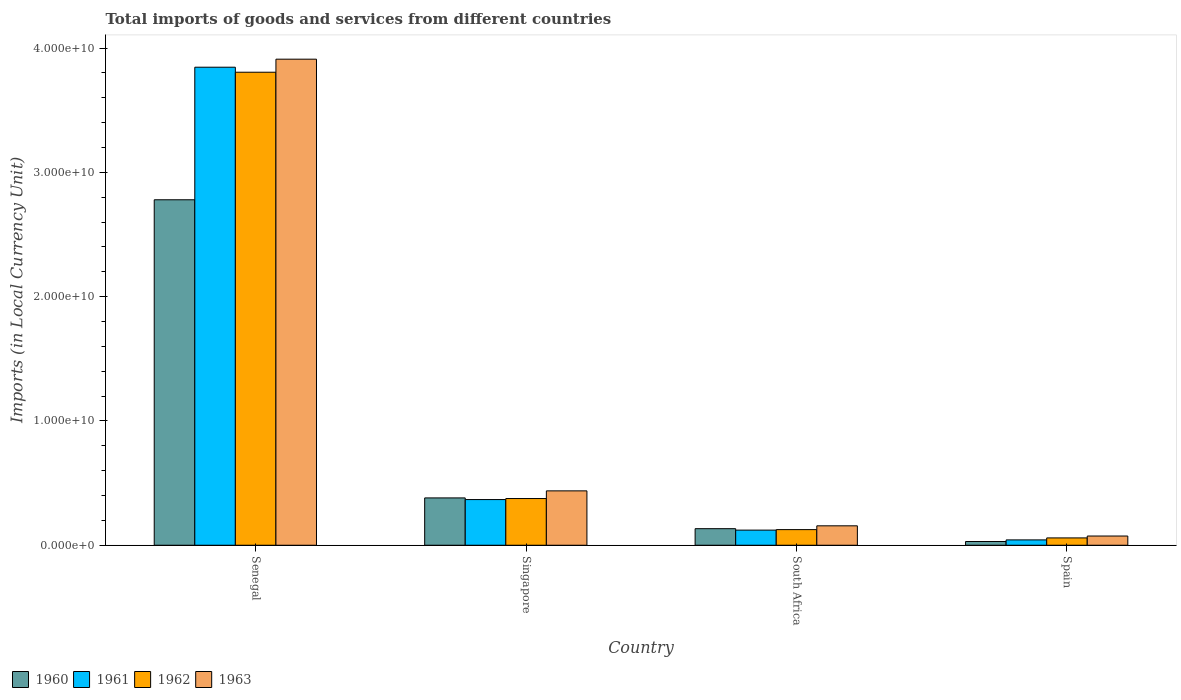Are the number of bars on each tick of the X-axis equal?
Keep it short and to the point. Yes. How many bars are there on the 3rd tick from the left?
Provide a succinct answer. 4. How many bars are there on the 1st tick from the right?
Keep it short and to the point. 4. What is the Amount of goods and services imports in 1962 in Spain?
Your response must be concise. 5.89e+08. Across all countries, what is the maximum Amount of goods and services imports in 1963?
Make the answer very short. 3.91e+1. Across all countries, what is the minimum Amount of goods and services imports in 1960?
Your response must be concise. 3.00e+08. In which country was the Amount of goods and services imports in 1963 maximum?
Provide a short and direct response. Senegal. What is the total Amount of goods and services imports in 1960 in the graph?
Provide a succinct answer. 3.32e+1. What is the difference between the Amount of goods and services imports in 1961 in Senegal and that in Singapore?
Provide a short and direct response. 3.48e+1. What is the difference between the Amount of goods and services imports in 1962 in Singapore and the Amount of goods and services imports in 1963 in Senegal?
Offer a terse response. -3.53e+1. What is the average Amount of goods and services imports in 1963 per country?
Offer a terse response. 1.14e+1. What is the difference between the Amount of goods and services imports of/in 1962 and Amount of goods and services imports of/in 1963 in South Africa?
Your answer should be compact. -3.06e+08. What is the ratio of the Amount of goods and services imports in 1962 in Singapore to that in Spain?
Offer a terse response. 6.38. What is the difference between the highest and the second highest Amount of goods and services imports in 1963?
Provide a short and direct response. -3.47e+1. What is the difference between the highest and the lowest Amount of goods and services imports in 1963?
Your response must be concise. 3.84e+1. In how many countries, is the Amount of goods and services imports in 1960 greater than the average Amount of goods and services imports in 1960 taken over all countries?
Give a very brief answer. 1. What does the 1st bar from the left in Singapore represents?
Ensure brevity in your answer.  1960. What does the 3rd bar from the right in South Africa represents?
Your answer should be very brief. 1961. How many bars are there?
Your response must be concise. 16. Are all the bars in the graph horizontal?
Make the answer very short. No. What is the difference between two consecutive major ticks on the Y-axis?
Your response must be concise. 1.00e+1. Are the values on the major ticks of Y-axis written in scientific E-notation?
Keep it short and to the point. Yes. Does the graph contain any zero values?
Your answer should be very brief. No. Where does the legend appear in the graph?
Make the answer very short. Bottom left. What is the title of the graph?
Offer a terse response. Total imports of goods and services from different countries. What is the label or title of the X-axis?
Offer a terse response. Country. What is the label or title of the Y-axis?
Your answer should be compact. Imports (in Local Currency Unit). What is the Imports (in Local Currency Unit) in 1960 in Senegal?
Provide a succinct answer. 2.78e+1. What is the Imports (in Local Currency Unit) of 1961 in Senegal?
Your answer should be compact. 3.85e+1. What is the Imports (in Local Currency Unit) in 1962 in Senegal?
Offer a very short reply. 3.81e+1. What is the Imports (in Local Currency Unit) in 1963 in Senegal?
Ensure brevity in your answer.  3.91e+1. What is the Imports (in Local Currency Unit) of 1960 in Singapore?
Your answer should be very brief. 3.81e+09. What is the Imports (in Local Currency Unit) of 1961 in Singapore?
Provide a succinct answer. 3.67e+09. What is the Imports (in Local Currency Unit) of 1962 in Singapore?
Offer a very short reply. 3.76e+09. What is the Imports (in Local Currency Unit) in 1963 in Singapore?
Provide a succinct answer. 4.37e+09. What is the Imports (in Local Currency Unit) of 1960 in South Africa?
Ensure brevity in your answer.  1.33e+09. What is the Imports (in Local Currency Unit) in 1961 in South Africa?
Offer a very short reply. 1.22e+09. What is the Imports (in Local Currency Unit) in 1962 in South Africa?
Keep it short and to the point. 1.26e+09. What is the Imports (in Local Currency Unit) in 1963 in South Africa?
Your response must be concise. 1.56e+09. What is the Imports (in Local Currency Unit) of 1960 in Spain?
Your answer should be compact. 3.00e+08. What is the Imports (in Local Currency Unit) in 1961 in Spain?
Ensure brevity in your answer.  4.29e+08. What is the Imports (in Local Currency Unit) of 1962 in Spain?
Ensure brevity in your answer.  5.89e+08. What is the Imports (in Local Currency Unit) of 1963 in Spain?
Offer a very short reply. 7.42e+08. Across all countries, what is the maximum Imports (in Local Currency Unit) of 1960?
Give a very brief answer. 2.78e+1. Across all countries, what is the maximum Imports (in Local Currency Unit) of 1961?
Give a very brief answer. 3.85e+1. Across all countries, what is the maximum Imports (in Local Currency Unit) of 1962?
Provide a short and direct response. 3.81e+1. Across all countries, what is the maximum Imports (in Local Currency Unit) in 1963?
Ensure brevity in your answer.  3.91e+1. Across all countries, what is the minimum Imports (in Local Currency Unit) of 1960?
Your answer should be compact. 3.00e+08. Across all countries, what is the minimum Imports (in Local Currency Unit) of 1961?
Keep it short and to the point. 4.29e+08. Across all countries, what is the minimum Imports (in Local Currency Unit) in 1962?
Provide a succinct answer. 5.89e+08. Across all countries, what is the minimum Imports (in Local Currency Unit) of 1963?
Your response must be concise. 7.42e+08. What is the total Imports (in Local Currency Unit) in 1960 in the graph?
Your answer should be compact. 3.32e+1. What is the total Imports (in Local Currency Unit) of 1961 in the graph?
Offer a very short reply. 4.38e+1. What is the total Imports (in Local Currency Unit) of 1962 in the graph?
Keep it short and to the point. 4.37e+1. What is the total Imports (in Local Currency Unit) of 1963 in the graph?
Your answer should be very brief. 4.58e+1. What is the difference between the Imports (in Local Currency Unit) of 1960 in Senegal and that in Singapore?
Make the answer very short. 2.40e+1. What is the difference between the Imports (in Local Currency Unit) in 1961 in Senegal and that in Singapore?
Ensure brevity in your answer.  3.48e+1. What is the difference between the Imports (in Local Currency Unit) of 1962 in Senegal and that in Singapore?
Your response must be concise. 3.43e+1. What is the difference between the Imports (in Local Currency Unit) in 1963 in Senegal and that in Singapore?
Offer a very short reply. 3.47e+1. What is the difference between the Imports (in Local Currency Unit) in 1960 in Senegal and that in South Africa?
Provide a short and direct response. 2.65e+1. What is the difference between the Imports (in Local Currency Unit) of 1961 in Senegal and that in South Africa?
Make the answer very short. 3.72e+1. What is the difference between the Imports (in Local Currency Unit) in 1962 in Senegal and that in South Africa?
Offer a terse response. 3.68e+1. What is the difference between the Imports (in Local Currency Unit) of 1963 in Senegal and that in South Africa?
Your response must be concise. 3.75e+1. What is the difference between the Imports (in Local Currency Unit) of 1960 in Senegal and that in Spain?
Offer a terse response. 2.75e+1. What is the difference between the Imports (in Local Currency Unit) in 1961 in Senegal and that in Spain?
Your answer should be very brief. 3.80e+1. What is the difference between the Imports (in Local Currency Unit) of 1962 in Senegal and that in Spain?
Keep it short and to the point. 3.75e+1. What is the difference between the Imports (in Local Currency Unit) in 1963 in Senegal and that in Spain?
Your answer should be compact. 3.84e+1. What is the difference between the Imports (in Local Currency Unit) in 1960 in Singapore and that in South Africa?
Provide a succinct answer. 2.48e+09. What is the difference between the Imports (in Local Currency Unit) in 1961 in Singapore and that in South Africa?
Your answer should be very brief. 2.46e+09. What is the difference between the Imports (in Local Currency Unit) of 1962 in Singapore and that in South Africa?
Ensure brevity in your answer.  2.50e+09. What is the difference between the Imports (in Local Currency Unit) of 1963 in Singapore and that in South Africa?
Keep it short and to the point. 2.81e+09. What is the difference between the Imports (in Local Currency Unit) in 1960 in Singapore and that in Spain?
Provide a short and direct response. 3.51e+09. What is the difference between the Imports (in Local Currency Unit) of 1961 in Singapore and that in Spain?
Make the answer very short. 3.25e+09. What is the difference between the Imports (in Local Currency Unit) in 1962 in Singapore and that in Spain?
Your response must be concise. 3.17e+09. What is the difference between the Imports (in Local Currency Unit) in 1963 in Singapore and that in Spain?
Keep it short and to the point. 3.63e+09. What is the difference between the Imports (in Local Currency Unit) in 1960 in South Africa and that in Spain?
Your answer should be very brief. 1.03e+09. What is the difference between the Imports (in Local Currency Unit) of 1961 in South Africa and that in Spain?
Make the answer very short. 7.87e+08. What is the difference between the Imports (in Local Currency Unit) of 1962 in South Africa and that in Spain?
Offer a very short reply. 6.68e+08. What is the difference between the Imports (in Local Currency Unit) in 1963 in South Africa and that in Spain?
Your answer should be compact. 8.21e+08. What is the difference between the Imports (in Local Currency Unit) of 1960 in Senegal and the Imports (in Local Currency Unit) of 1961 in Singapore?
Your answer should be very brief. 2.41e+1. What is the difference between the Imports (in Local Currency Unit) in 1960 in Senegal and the Imports (in Local Currency Unit) in 1962 in Singapore?
Your response must be concise. 2.40e+1. What is the difference between the Imports (in Local Currency Unit) of 1960 in Senegal and the Imports (in Local Currency Unit) of 1963 in Singapore?
Offer a terse response. 2.34e+1. What is the difference between the Imports (in Local Currency Unit) of 1961 in Senegal and the Imports (in Local Currency Unit) of 1962 in Singapore?
Give a very brief answer. 3.47e+1. What is the difference between the Imports (in Local Currency Unit) of 1961 in Senegal and the Imports (in Local Currency Unit) of 1963 in Singapore?
Your answer should be very brief. 3.41e+1. What is the difference between the Imports (in Local Currency Unit) in 1962 in Senegal and the Imports (in Local Currency Unit) in 1963 in Singapore?
Your answer should be very brief. 3.37e+1. What is the difference between the Imports (in Local Currency Unit) of 1960 in Senegal and the Imports (in Local Currency Unit) of 1961 in South Africa?
Provide a succinct answer. 2.66e+1. What is the difference between the Imports (in Local Currency Unit) in 1960 in Senegal and the Imports (in Local Currency Unit) in 1962 in South Africa?
Offer a terse response. 2.65e+1. What is the difference between the Imports (in Local Currency Unit) in 1960 in Senegal and the Imports (in Local Currency Unit) in 1963 in South Africa?
Provide a succinct answer. 2.62e+1. What is the difference between the Imports (in Local Currency Unit) in 1961 in Senegal and the Imports (in Local Currency Unit) in 1962 in South Africa?
Keep it short and to the point. 3.72e+1. What is the difference between the Imports (in Local Currency Unit) in 1961 in Senegal and the Imports (in Local Currency Unit) in 1963 in South Africa?
Keep it short and to the point. 3.69e+1. What is the difference between the Imports (in Local Currency Unit) of 1962 in Senegal and the Imports (in Local Currency Unit) of 1963 in South Africa?
Provide a succinct answer. 3.65e+1. What is the difference between the Imports (in Local Currency Unit) of 1960 in Senegal and the Imports (in Local Currency Unit) of 1961 in Spain?
Your response must be concise. 2.74e+1. What is the difference between the Imports (in Local Currency Unit) in 1960 in Senegal and the Imports (in Local Currency Unit) in 1962 in Spain?
Ensure brevity in your answer.  2.72e+1. What is the difference between the Imports (in Local Currency Unit) of 1960 in Senegal and the Imports (in Local Currency Unit) of 1963 in Spain?
Offer a terse response. 2.71e+1. What is the difference between the Imports (in Local Currency Unit) in 1961 in Senegal and the Imports (in Local Currency Unit) in 1962 in Spain?
Give a very brief answer. 3.79e+1. What is the difference between the Imports (in Local Currency Unit) in 1961 in Senegal and the Imports (in Local Currency Unit) in 1963 in Spain?
Your answer should be compact. 3.77e+1. What is the difference between the Imports (in Local Currency Unit) in 1962 in Senegal and the Imports (in Local Currency Unit) in 1963 in Spain?
Provide a succinct answer. 3.73e+1. What is the difference between the Imports (in Local Currency Unit) in 1960 in Singapore and the Imports (in Local Currency Unit) in 1961 in South Africa?
Give a very brief answer. 2.59e+09. What is the difference between the Imports (in Local Currency Unit) of 1960 in Singapore and the Imports (in Local Currency Unit) of 1962 in South Africa?
Offer a very short reply. 2.55e+09. What is the difference between the Imports (in Local Currency Unit) in 1960 in Singapore and the Imports (in Local Currency Unit) in 1963 in South Africa?
Offer a terse response. 2.25e+09. What is the difference between the Imports (in Local Currency Unit) of 1961 in Singapore and the Imports (in Local Currency Unit) of 1962 in South Africa?
Provide a succinct answer. 2.42e+09. What is the difference between the Imports (in Local Currency Unit) in 1961 in Singapore and the Imports (in Local Currency Unit) in 1963 in South Africa?
Offer a very short reply. 2.11e+09. What is the difference between the Imports (in Local Currency Unit) in 1962 in Singapore and the Imports (in Local Currency Unit) in 1963 in South Africa?
Ensure brevity in your answer.  2.19e+09. What is the difference between the Imports (in Local Currency Unit) in 1960 in Singapore and the Imports (in Local Currency Unit) in 1961 in Spain?
Your response must be concise. 3.38e+09. What is the difference between the Imports (in Local Currency Unit) of 1960 in Singapore and the Imports (in Local Currency Unit) of 1962 in Spain?
Make the answer very short. 3.22e+09. What is the difference between the Imports (in Local Currency Unit) in 1960 in Singapore and the Imports (in Local Currency Unit) in 1963 in Spain?
Provide a short and direct response. 3.07e+09. What is the difference between the Imports (in Local Currency Unit) of 1961 in Singapore and the Imports (in Local Currency Unit) of 1962 in Spain?
Keep it short and to the point. 3.09e+09. What is the difference between the Imports (in Local Currency Unit) in 1961 in Singapore and the Imports (in Local Currency Unit) in 1963 in Spain?
Provide a short and direct response. 2.93e+09. What is the difference between the Imports (in Local Currency Unit) of 1962 in Singapore and the Imports (in Local Currency Unit) of 1963 in Spain?
Your answer should be very brief. 3.02e+09. What is the difference between the Imports (in Local Currency Unit) of 1960 in South Africa and the Imports (in Local Currency Unit) of 1961 in Spain?
Ensure brevity in your answer.  9.03e+08. What is the difference between the Imports (in Local Currency Unit) of 1960 in South Africa and the Imports (in Local Currency Unit) of 1962 in Spain?
Your response must be concise. 7.43e+08. What is the difference between the Imports (in Local Currency Unit) in 1960 in South Africa and the Imports (in Local Currency Unit) in 1963 in Spain?
Make the answer very short. 5.90e+08. What is the difference between the Imports (in Local Currency Unit) in 1961 in South Africa and the Imports (in Local Currency Unit) in 1962 in Spain?
Keep it short and to the point. 6.27e+08. What is the difference between the Imports (in Local Currency Unit) in 1961 in South Africa and the Imports (in Local Currency Unit) in 1963 in Spain?
Make the answer very short. 4.74e+08. What is the difference between the Imports (in Local Currency Unit) in 1962 in South Africa and the Imports (in Local Currency Unit) in 1963 in Spain?
Keep it short and to the point. 5.15e+08. What is the average Imports (in Local Currency Unit) in 1960 per country?
Keep it short and to the point. 8.31e+09. What is the average Imports (in Local Currency Unit) in 1961 per country?
Make the answer very short. 1.09e+1. What is the average Imports (in Local Currency Unit) in 1962 per country?
Provide a short and direct response. 1.09e+1. What is the average Imports (in Local Currency Unit) in 1963 per country?
Your response must be concise. 1.14e+1. What is the difference between the Imports (in Local Currency Unit) of 1960 and Imports (in Local Currency Unit) of 1961 in Senegal?
Give a very brief answer. -1.07e+1. What is the difference between the Imports (in Local Currency Unit) of 1960 and Imports (in Local Currency Unit) of 1962 in Senegal?
Your answer should be compact. -1.03e+1. What is the difference between the Imports (in Local Currency Unit) in 1960 and Imports (in Local Currency Unit) in 1963 in Senegal?
Ensure brevity in your answer.  -1.13e+1. What is the difference between the Imports (in Local Currency Unit) in 1961 and Imports (in Local Currency Unit) in 1962 in Senegal?
Give a very brief answer. 4.04e+08. What is the difference between the Imports (in Local Currency Unit) of 1961 and Imports (in Local Currency Unit) of 1963 in Senegal?
Your answer should be very brief. -6.46e+08. What is the difference between the Imports (in Local Currency Unit) in 1962 and Imports (in Local Currency Unit) in 1963 in Senegal?
Ensure brevity in your answer.  -1.05e+09. What is the difference between the Imports (in Local Currency Unit) in 1960 and Imports (in Local Currency Unit) in 1961 in Singapore?
Your answer should be compact. 1.33e+08. What is the difference between the Imports (in Local Currency Unit) of 1960 and Imports (in Local Currency Unit) of 1962 in Singapore?
Make the answer very short. 5.08e+07. What is the difference between the Imports (in Local Currency Unit) in 1960 and Imports (in Local Currency Unit) in 1963 in Singapore?
Keep it short and to the point. -5.67e+08. What is the difference between the Imports (in Local Currency Unit) of 1961 and Imports (in Local Currency Unit) of 1962 in Singapore?
Keep it short and to the point. -8.22e+07. What is the difference between the Imports (in Local Currency Unit) in 1961 and Imports (in Local Currency Unit) in 1963 in Singapore?
Keep it short and to the point. -7.00e+08. What is the difference between the Imports (in Local Currency Unit) of 1962 and Imports (in Local Currency Unit) of 1963 in Singapore?
Your response must be concise. -6.18e+08. What is the difference between the Imports (in Local Currency Unit) in 1960 and Imports (in Local Currency Unit) in 1961 in South Africa?
Offer a terse response. 1.16e+08. What is the difference between the Imports (in Local Currency Unit) of 1960 and Imports (in Local Currency Unit) of 1962 in South Africa?
Provide a succinct answer. 7.51e+07. What is the difference between the Imports (in Local Currency Unit) of 1960 and Imports (in Local Currency Unit) of 1963 in South Africa?
Ensure brevity in your answer.  -2.30e+08. What is the difference between the Imports (in Local Currency Unit) in 1961 and Imports (in Local Currency Unit) in 1962 in South Africa?
Provide a short and direct response. -4.06e+07. What is the difference between the Imports (in Local Currency Unit) in 1961 and Imports (in Local Currency Unit) in 1963 in South Africa?
Offer a very short reply. -3.46e+08. What is the difference between the Imports (in Local Currency Unit) of 1962 and Imports (in Local Currency Unit) of 1963 in South Africa?
Offer a terse response. -3.06e+08. What is the difference between the Imports (in Local Currency Unit) in 1960 and Imports (in Local Currency Unit) in 1961 in Spain?
Your response must be concise. -1.29e+08. What is the difference between the Imports (in Local Currency Unit) of 1960 and Imports (in Local Currency Unit) of 1962 in Spain?
Give a very brief answer. -2.88e+08. What is the difference between the Imports (in Local Currency Unit) of 1960 and Imports (in Local Currency Unit) of 1963 in Spain?
Your answer should be compact. -4.41e+08. What is the difference between the Imports (in Local Currency Unit) of 1961 and Imports (in Local Currency Unit) of 1962 in Spain?
Give a very brief answer. -1.60e+08. What is the difference between the Imports (in Local Currency Unit) of 1961 and Imports (in Local Currency Unit) of 1963 in Spain?
Give a very brief answer. -3.12e+08. What is the difference between the Imports (in Local Currency Unit) in 1962 and Imports (in Local Currency Unit) in 1963 in Spain?
Your response must be concise. -1.53e+08. What is the ratio of the Imports (in Local Currency Unit) in 1960 in Senegal to that in Singapore?
Keep it short and to the point. 7.3. What is the ratio of the Imports (in Local Currency Unit) in 1961 in Senegal to that in Singapore?
Your answer should be very brief. 10.47. What is the ratio of the Imports (in Local Currency Unit) in 1962 in Senegal to that in Singapore?
Offer a terse response. 10.13. What is the ratio of the Imports (in Local Currency Unit) in 1963 in Senegal to that in Singapore?
Your answer should be compact. 8.94. What is the ratio of the Imports (in Local Currency Unit) of 1960 in Senegal to that in South Africa?
Offer a terse response. 20.87. What is the ratio of the Imports (in Local Currency Unit) of 1961 in Senegal to that in South Africa?
Give a very brief answer. 31.63. What is the ratio of the Imports (in Local Currency Unit) in 1962 in Senegal to that in South Africa?
Your answer should be compact. 30.28. What is the ratio of the Imports (in Local Currency Unit) of 1963 in Senegal to that in South Africa?
Make the answer very short. 25.03. What is the ratio of the Imports (in Local Currency Unit) of 1960 in Senegal to that in Spain?
Your answer should be very brief. 92.51. What is the ratio of the Imports (in Local Currency Unit) in 1961 in Senegal to that in Spain?
Your answer should be compact. 89.62. What is the ratio of the Imports (in Local Currency Unit) of 1962 in Senegal to that in Spain?
Provide a succinct answer. 64.62. What is the ratio of the Imports (in Local Currency Unit) in 1963 in Senegal to that in Spain?
Your answer should be compact. 52.73. What is the ratio of the Imports (in Local Currency Unit) of 1960 in Singapore to that in South Africa?
Your answer should be very brief. 2.86. What is the ratio of the Imports (in Local Currency Unit) in 1961 in Singapore to that in South Africa?
Offer a terse response. 3.02. What is the ratio of the Imports (in Local Currency Unit) in 1962 in Singapore to that in South Africa?
Give a very brief answer. 2.99. What is the ratio of the Imports (in Local Currency Unit) of 1963 in Singapore to that in South Africa?
Your answer should be very brief. 2.8. What is the ratio of the Imports (in Local Currency Unit) of 1960 in Singapore to that in Spain?
Ensure brevity in your answer.  12.67. What is the ratio of the Imports (in Local Currency Unit) of 1961 in Singapore to that in Spain?
Give a very brief answer. 8.56. What is the ratio of the Imports (in Local Currency Unit) of 1962 in Singapore to that in Spain?
Give a very brief answer. 6.38. What is the ratio of the Imports (in Local Currency Unit) in 1963 in Singapore to that in Spain?
Give a very brief answer. 5.9. What is the ratio of the Imports (in Local Currency Unit) of 1960 in South Africa to that in Spain?
Offer a very short reply. 4.43. What is the ratio of the Imports (in Local Currency Unit) in 1961 in South Africa to that in Spain?
Make the answer very short. 2.83. What is the ratio of the Imports (in Local Currency Unit) in 1962 in South Africa to that in Spain?
Your answer should be very brief. 2.13. What is the ratio of the Imports (in Local Currency Unit) in 1963 in South Africa to that in Spain?
Your response must be concise. 2.11. What is the difference between the highest and the second highest Imports (in Local Currency Unit) of 1960?
Your response must be concise. 2.40e+1. What is the difference between the highest and the second highest Imports (in Local Currency Unit) in 1961?
Your answer should be compact. 3.48e+1. What is the difference between the highest and the second highest Imports (in Local Currency Unit) in 1962?
Offer a very short reply. 3.43e+1. What is the difference between the highest and the second highest Imports (in Local Currency Unit) of 1963?
Ensure brevity in your answer.  3.47e+1. What is the difference between the highest and the lowest Imports (in Local Currency Unit) in 1960?
Make the answer very short. 2.75e+1. What is the difference between the highest and the lowest Imports (in Local Currency Unit) in 1961?
Offer a terse response. 3.80e+1. What is the difference between the highest and the lowest Imports (in Local Currency Unit) of 1962?
Make the answer very short. 3.75e+1. What is the difference between the highest and the lowest Imports (in Local Currency Unit) of 1963?
Provide a succinct answer. 3.84e+1. 